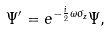Convert formula to latex. <formula><loc_0><loc_0><loc_500><loc_500>\Psi ^ { \prime } = e ^ { - \frac { i } { 2 } \omega \sigma _ { z } } \Psi ,</formula> 